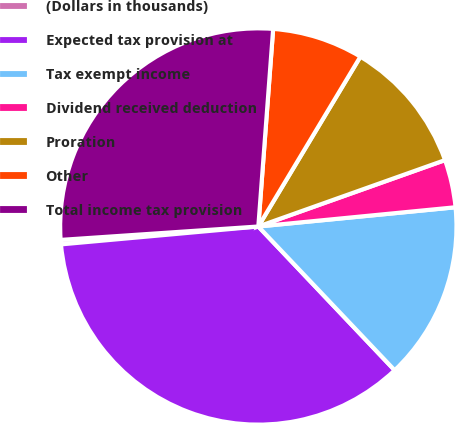<chart> <loc_0><loc_0><loc_500><loc_500><pie_chart><fcel>(Dollars in thousands)<fcel>Expected tax provision at<fcel>Tax exempt income<fcel>Dividend received deduction<fcel>Proration<fcel>Other<fcel>Total income tax provision<nl><fcel>0.36%<fcel>35.64%<fcel>14.47%<fcel>3.89%<fcel>10.95%<fcel>7.42%<fcel>27.27%<nl></chart> 